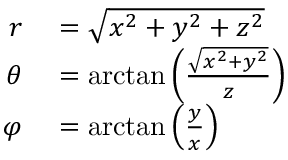<formula> <loc_0><loc_0><loc_500><loc_500>\begin{array} { r l } { r } & = { \sqrt { x ^ { 2 } + y ^ { 2 } + z ^ { 2 } } } } \\ { \theta } & = \arctan \left ( { \frac { \sqrt { x ^ { 2 } + y ^ { 2 } } } { z } } \right ) } \\ { \varphi } & = \arctan \left ( { \frac { y } { x } } \right ) } \end{array}</formula> 